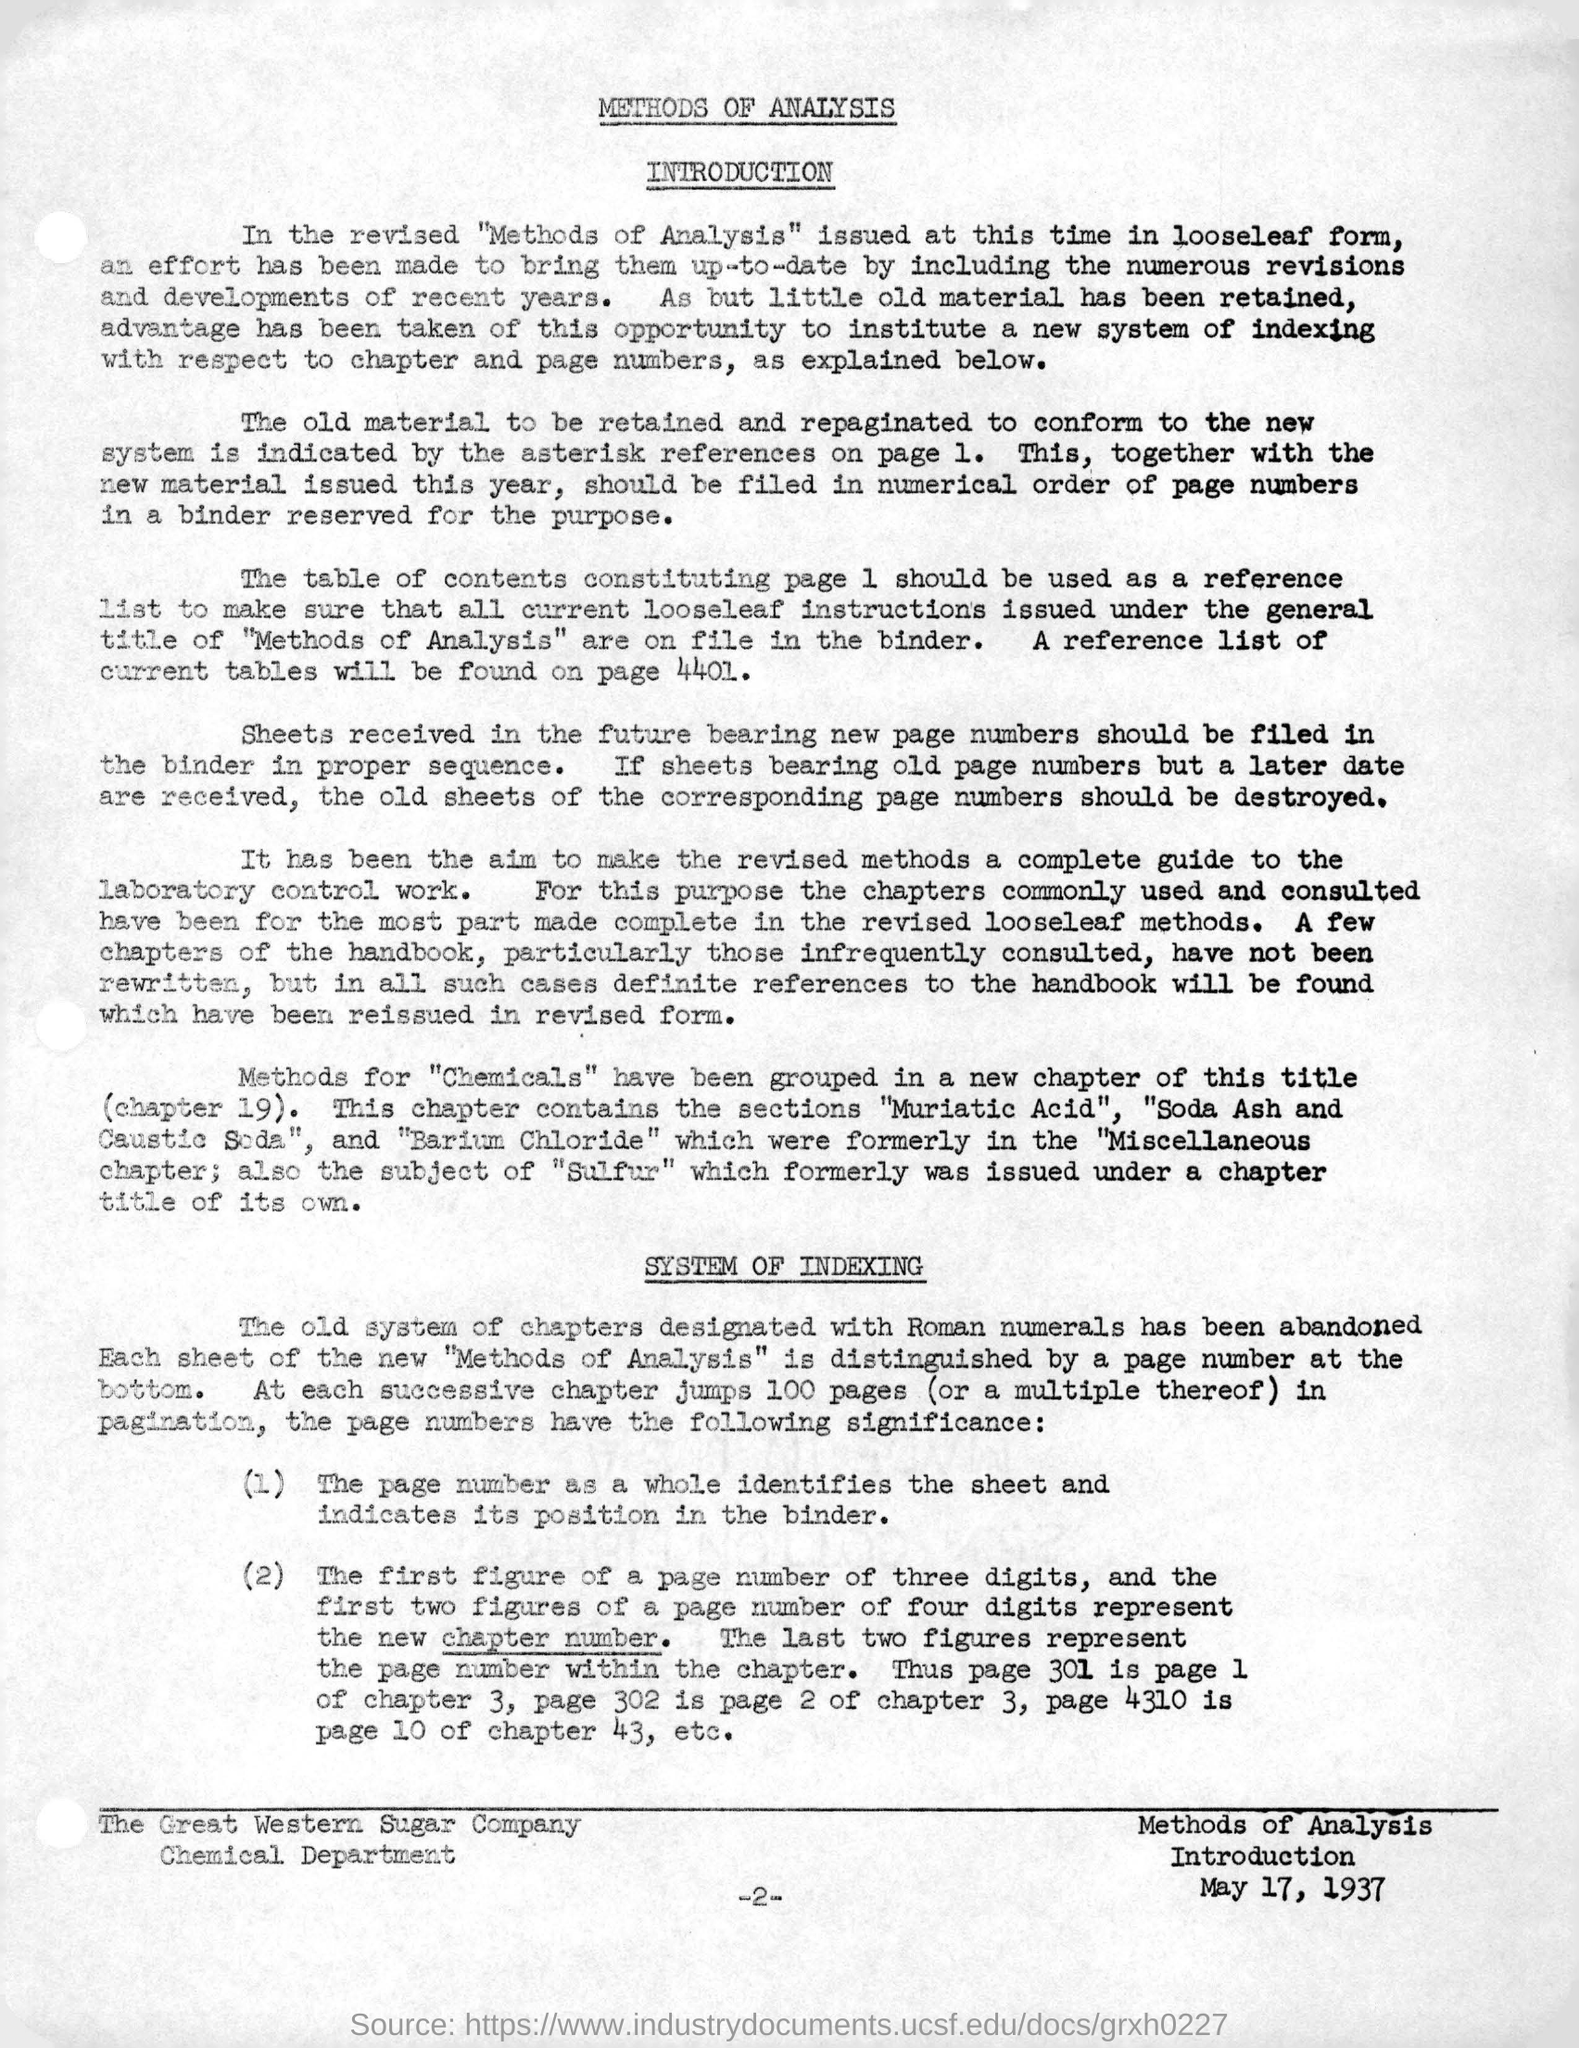Indicate a few pertinent items in this graphic. The date mentioned in the right-hand bottom corner of the document is May 17, 1937. This document is about the methods of analysis used to obtain information about a topic. The reference list for the current tables can be found on page 4401. The main title of the document is 'Methods of Analysis.' 